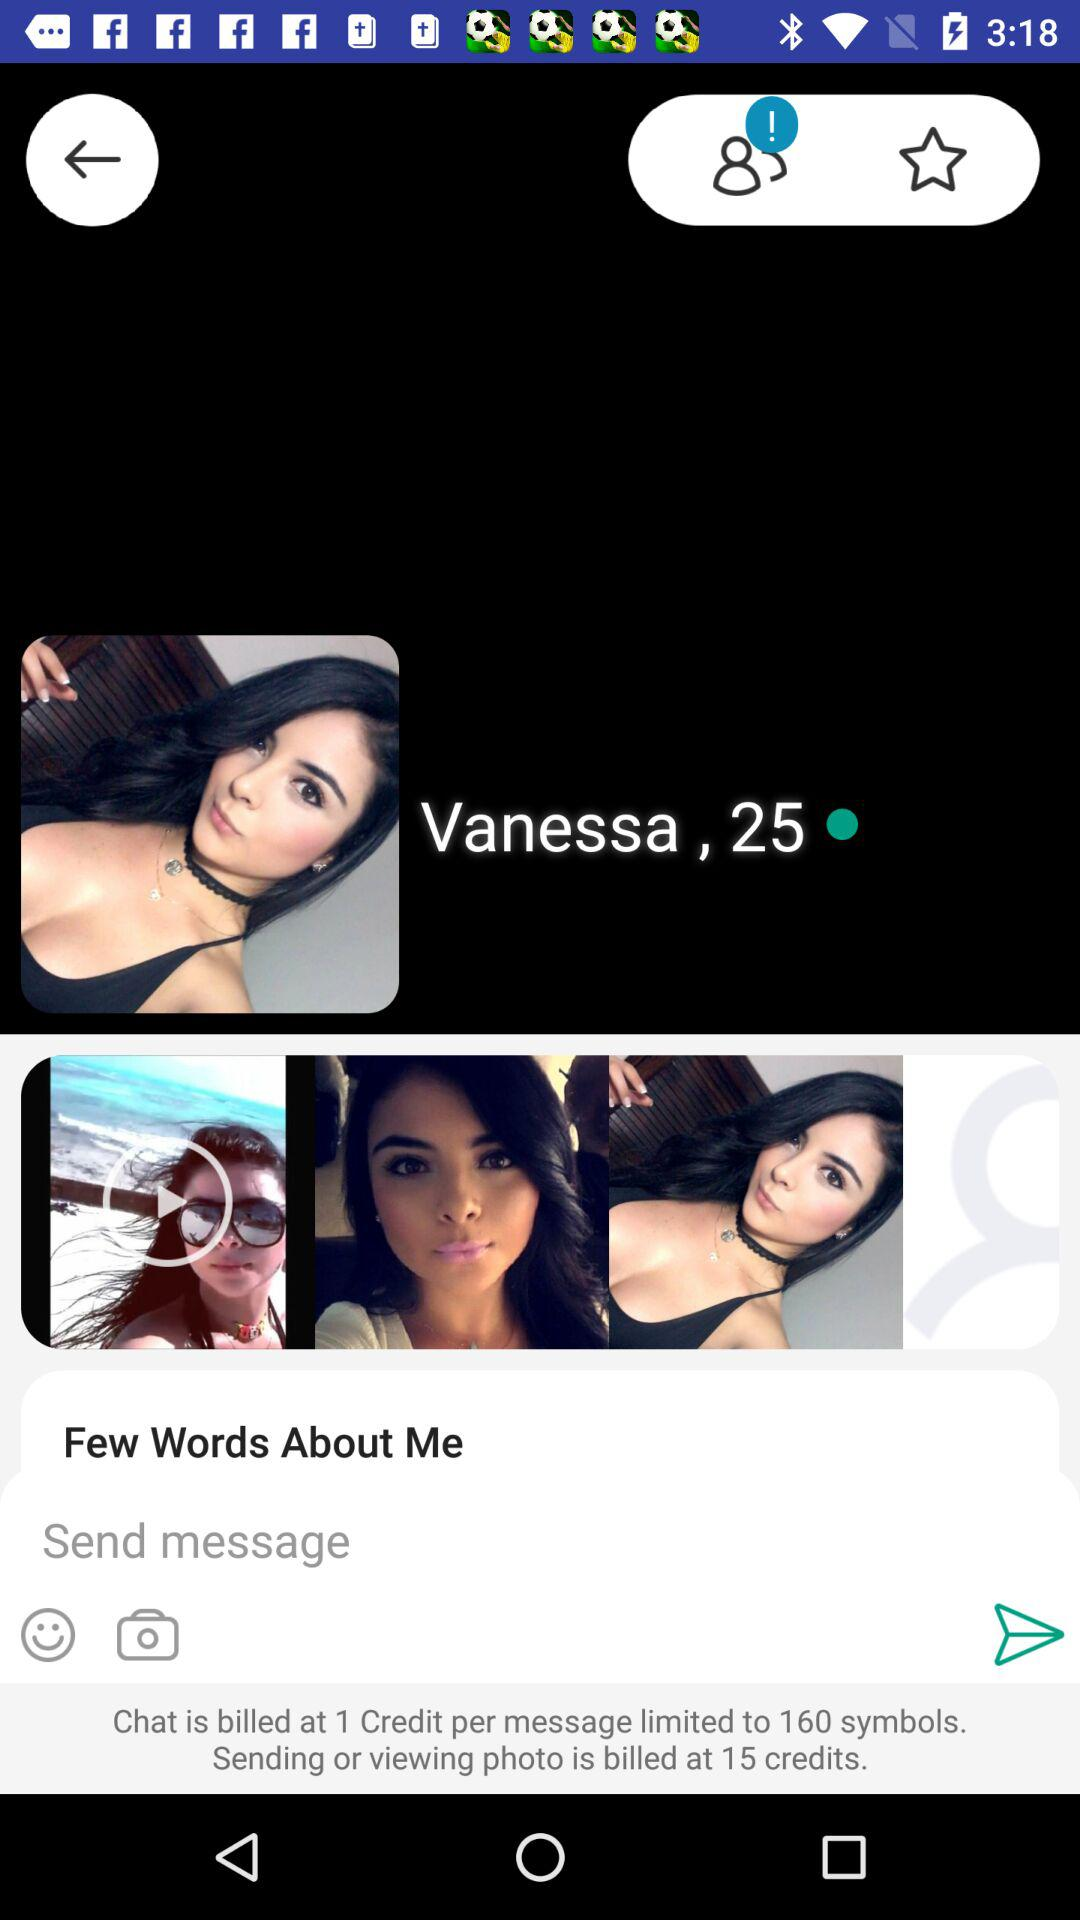What is the user name? The user name is Vanessa. 